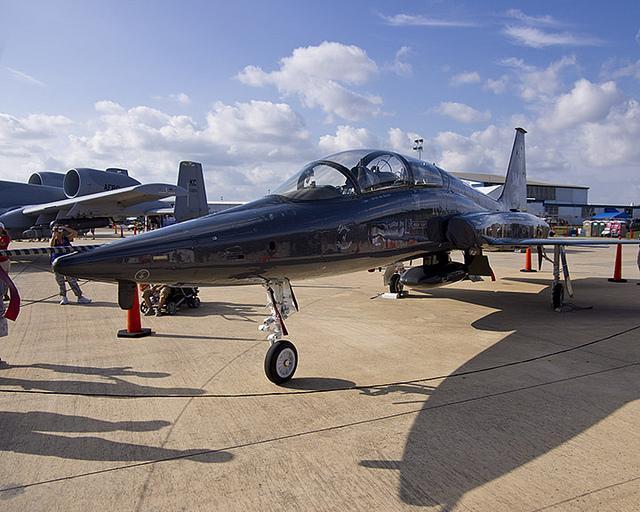How many wheels on the plane?
Give a very brief answer. 3. How many airplanes are there?
Give a very brief answer. 2. How many horses do you see?
Give a very brief answer. 0. 